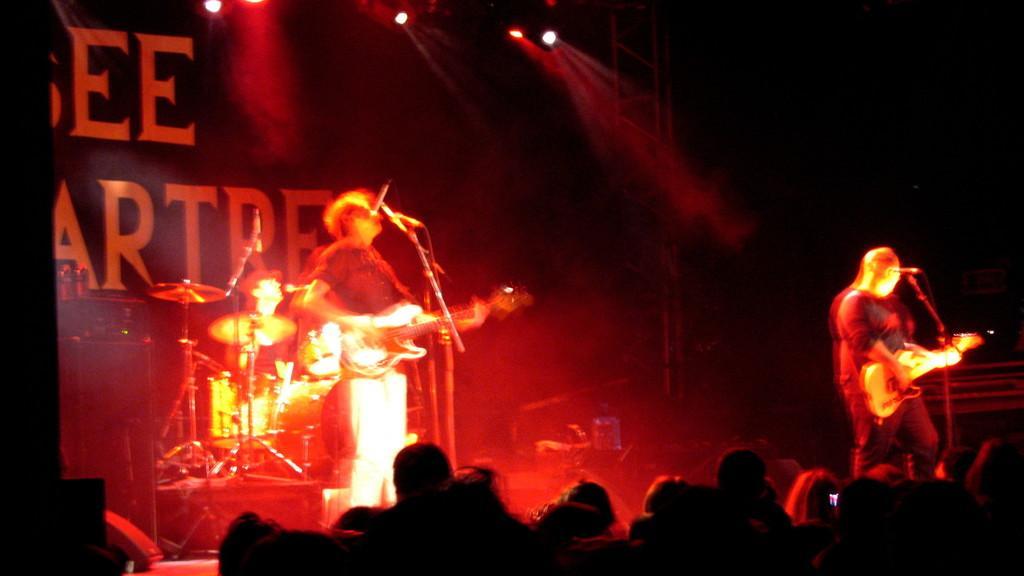Describe this image in one or two sentences. In the center of the image we can see two persons are standing on the stage holding guitars in their hands, two microphones are placed on the stands. On the left side of the image we can see a person sitting in front of musical instruments. In the foreground we can see group of people. In the background we can see group of lights and banner. 